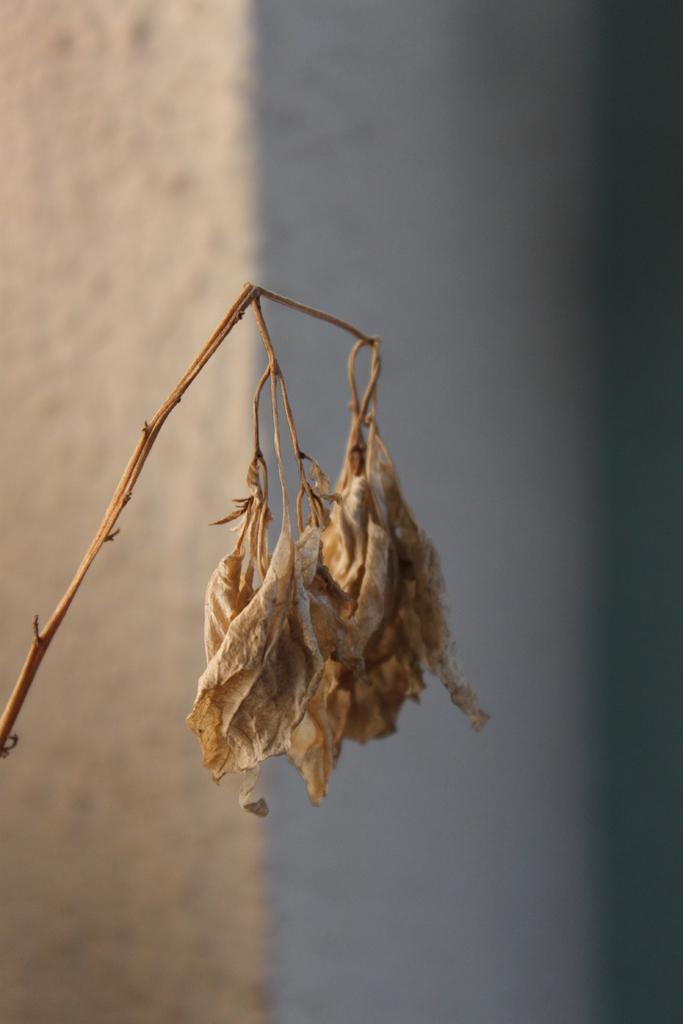In one or two sentences, can you explain what this image depicts? In the picture we can see a dried small plant with flowers and in the background, we can see a wall which is white in color. 